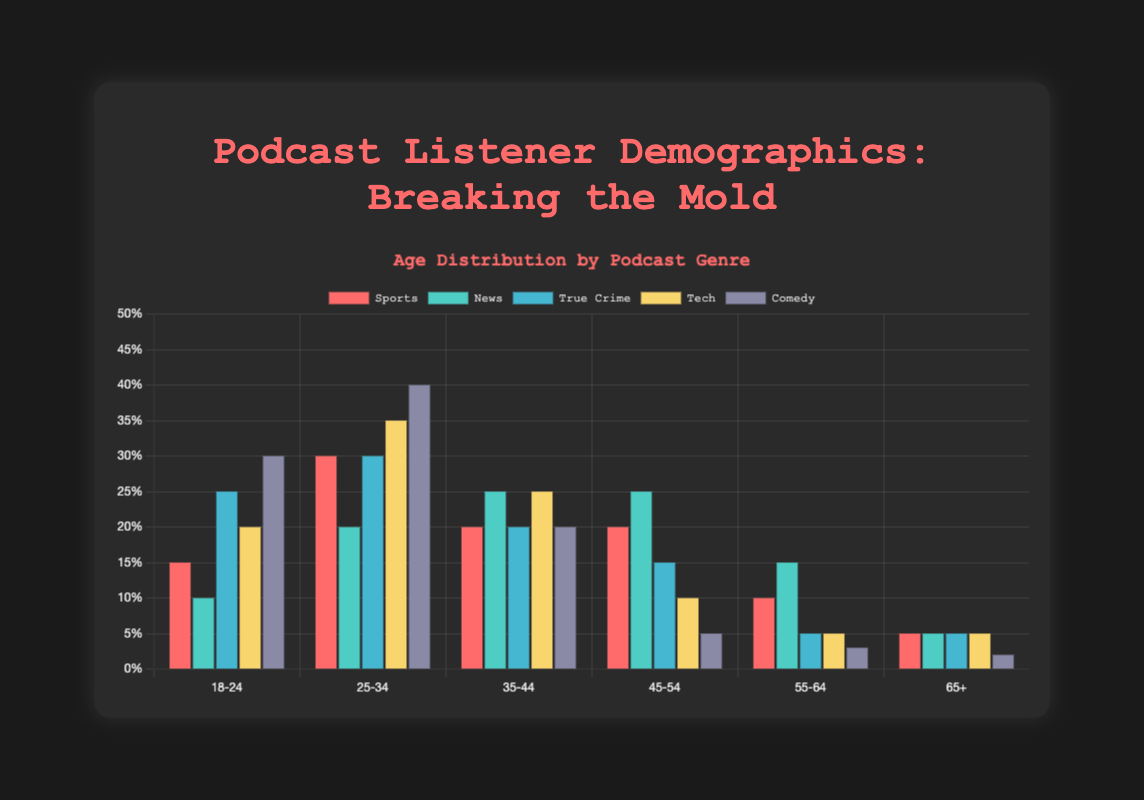Which age group has the highest percentage of listeners for Comedy podcasts? The Comedy genre bars can be visually inspected to identify the tallest bar, which represents the 25-34 age group at 40%.
Answer: 25-34 How does the percentage of 18-24 listeners in Sports compare to that in True Crime? The height of the bars for 18-24 age group in both genres shows True Crime at 25% and Sports at 15%, so True Crime is higher.
Answer: True Crime What is the difference in percentage between 25-34 listeners of Tech and News podcasts? The bars for the Tech and News genres for the 25-34 age group can be compared: Tech at 35% and News at 20%, resulting in a difference of 15%.
Answer: 15% Which genre has the lowest percentage of listeners in the 65+ age group? By inspecting the shortest bars in each genre for the 65+ age group, Comedy has the lowest at 2%.
Answer: Comedy What is the sum of the percentages of 35-44 and 45-54 listeners for Sports podcasts? The bars for Sports in the 35-44 age group (20%) and 45-54 age group (20%) add up to 40%.
Answer: 40% Does the Tech genre have more listeners aged 25-34 or 35-44? Comparing the height of the bars, the 25-34 age group for Tech is taller at 35% versus 25% for the 35-44 age group.
Answer: 25-34 What is the average percentage of listeners in the 18-24 age group across all genres? The percentages for 18-24 age group are: Sports (15), News (10), True Crime (25), Tech (20), Comedy (30). The average is (15+10+25+20+30)/5 = 20%.
Answer: 20% Compare the percentage of 45-54 listeners between News and True Crime genres. Which one is higher? The bars indicate that both News and True Crime have the same percentage, 25% and 15% respectively. News is higher.
Answer: News Which age group has the most even distribution of listeners across all genres? Finding the most similar heights across genres, the 55-64 and 65+ age groups appear consistent across the board, each showing small variance.
Answer: 65+ Of all the genres, which one has the highest percentage of listeners in the same age group? Checking all the bars, Comedy has the highest percentage in the 25-34 age group at 40%.
Answer: Comedy 